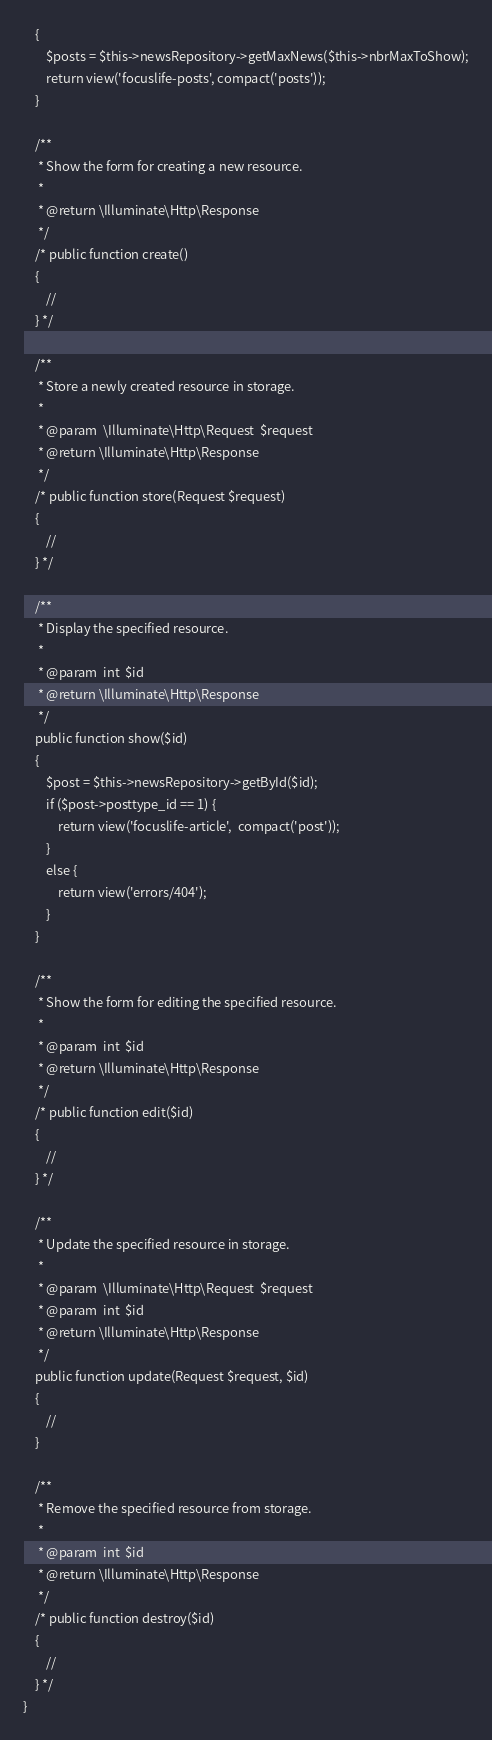<code> <loc_0><loc_0><loc_500><loc_500><_PHP_>    {
		$posts = $this->newsRepository->getMaxNews($this->nbrMaxToShow);
		return view('focuslife-posts', compact('posts'));
    }

    /**
     * Show the form for creating a new resource.
     *
     * @return \Illuminate\Http\Response
     */
    /* public function create()
    {
        //
    } */

    /**
     * Store a newly created resource in storage.
     *
     * @param  \Illuminate\Http\Request  $request
     * @return \Illuminate\Http\Response
     */
    /* public function store(Request $request)
    {
        //
    } */

    /**
     * Display the specified resource.
     *
     * @param  int  $id
     * @return \Illuminate\Http\Response
     */
	public function show($id)
	{
		$post = $this->newsRepository->getById($id);
		if ($post->posttype_id == 1) {
			return view('focuslife-article',  compact('post'));
		}
		else {
			return view('errors/404');
		}
	}

    /**
     * Show the form for editing the specified resource.
     *
     * @param  int  $id
     * @return \Illuminate\Http\Response
     */
    /* public function edit($id)
    {
        //
    } */

    /**
     * Update the specified resource in storage.
     *
     * @param  \Illuminate\Http\Request  $request
     * @param  int  $id
     * @return \Illuminate\Http\Response
     */
    public function update(Request $request, $id)
    {
        //
    }

    /**
     * Remove the specified resource from storage.
     *
     * @param  int  $id
     * @return \Illuminate\Http\Response
     */
    /* public function destroy($id)
    {
        //
    } */
}
</code> 